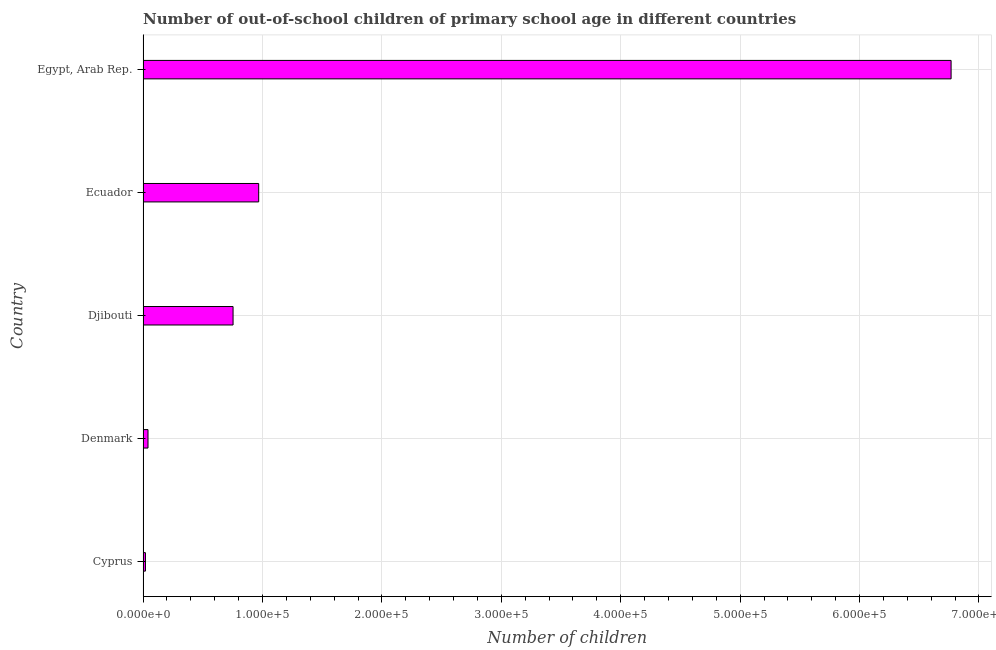Does the graph contain grids?
Your answer should be compact. Yes. What is the title of the graph?
Your response must be concise. Number of out-of-school children of primary school age in different countries. What is the label or title of the X-axis?
Make the answer very short. Number of children. What is the label or title of the Y-axis?
Offer a terse response. Country. What is the number of out-of-school children in Ecuador?
Your answer should be very brief. 9.68e+04. Across all countries, what is the maximum number of out-of-school children?
Offer a very short reply. 6.77e+05. Across all countries, what is the minimum number of out-of-school children?
Your response must be concise. 1986. In which country was the number of out-of-school children maximum?
Offer a very short reply. Egypt, Arab Rep. In which country was the number of out-of-school children minimum?
Your answer should be compact. Cyprus. What is the sum of the number of out-of-school children?
Your answer should be very brief. 8.55e+05. What is the difference between the number of out-of-school children in Denmark and Ecuador?
Provide a short and direct response. -9.27e+04. What is the average number of out-of-school children per country?
Your answer should be compact. 1.71e+05. What is the median number of out-of-school children?
Offer a very short reply. 7.54e+04. In how many countries, is the number of out-of-school children greater than 320000 ?
Give a very brief answer. 1. What is the ratio of the number of out-of-school children in Denmark to that in Egypt, Arab Rep.?
Give a very brief answer. 0.01. What is the difference between the highest and the second highest number of out-of-school children?
Your response must be concise. 5.80e+05. Is the sum of the number of out-of-school children in Cyprus and Djibouti greater than the maximum number of out-of-school children across all countries?
Keep it short and to the point. No. What is the difference between the highest and the lowest number of out-of-school children?
Keep it short and to the point. 6.75e+05. In how many countries, is the number of out-of-school children greater than the average number of out-of-school children taken over all countries?
Provide a short and direct response. 1. How many bars are there?
Give a very brief answer. 5. How many countries are there in the graph?
Ensure brevity in your answer.  5. Are the values on the major ticks of X-axis written in scientific E-notation?
Your answer should be compact. Yes. What is the Number of children in Cyprus?
Give a very brief answer. 1986. What is the Number of children in Denmark?
Make the answer very short. 4140. What is the Number of children of Djibouti?
Your answer should be very brief. 7.54e+04. What is the Number of children of Ecuador?
Provide a succinct answer. 9.68e+04. What is the Number of children in Egypt, Arab Rep.?
Your response must be concise. 6.77e+05. What is the difference between the Number of children in Cyprus and Denmark?
Provide a succinct answer. -2154. What is the difference between the Number of children in Cyprus and Djibouti?
Your answer should be very brief. -7.34e+04. What is the difference between the Number of children in Cyprus and Ecuador?
Your answer should be very brief. -9.48e+04. What is the difference between the Number of children in Cyprus and Egypt, Arab Rep.?
Provide a succinct answer. -6.75e+05. What is the difference between the Number of children in Denmark and Djibouti?
Keep it short and to the point. -7.12e+04. What is the difference between the Number of children in Denmark and Ecuador?
Provide a short and direct response. -9.27e+04. What is the difference between the Number of children in Denmark and Egypt, Arab Rep.?
Your response must be concise. -6.73e+05. What is the difference between the Number of children in Djibouti and Ecuador?
Your answer should be compact. -2.15e+04. What is the difference between the Number of children in Djibouti and Egypt, Arab Rep.?
Your response must be concise. -6.01e+05. What is the difference between the Number of children in Ecuador and Egypt, Arab Rep.?
Offer a very short reply. -5.80e+05. What is the ratio of the Number of children in Cyprus to that in Denmark?
Make the answer very short. 0.48. What is the ratio of the Number of children in Cyprus to that in Djibouti?
Your answer should be compact. 0.03. What is the ratio of the Number of children in Cyprus to that in Ecuador?
Your answer should be compact. 0.02. What is the ratio of the Number of children in Cyprus to that in Egypt, Arab Rep.?
Give a very brief answer. 0. What is the ratio of the Number of children in Denmark to that in Djibouti?
Provide a short and direct response. 0.06. What is the ratio of the Number of children in Denmark to that in Ecuador?
Give a very brief answer. 0.04. What is the ratio of the Number of children in Denmark to that in Egypt, Arab Rep.?
Offer a very short reply. 0.01. What is the ratio of the Number of children in Djibouti to that in Ecuador?
Make the answer very short. 0.78. What is the ratio of the Number of children in Djibouti to that in Egypt, Arab Rep.?
Make the answer very short. 0.11. What is the ratio of the Number of children in Ecuador to that in Egypt, Arab Rep.?
Keep it short and to the point. 0.14. 